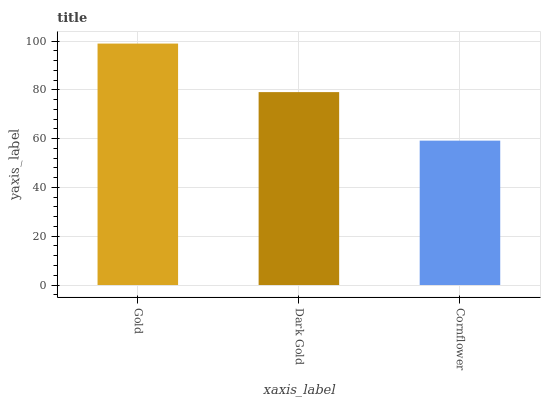Is Cornflower the minimum?
Answer yes or no. Yes. Is Gold the maximum?
Answer yes or no. Yes. Is Dark Gold the minimum?
Answer yes or no. No. Is Dark Gold the maximum?
Answer yes or no. No. Is Gold greater than Dark Gold?
Answer yes or no. Yes. Is Dark Gold less than Gold?
Answer yes or no. Yes. Is Dark Gold greater than Gold?
Answer yes or no. No. Is Gold less than Dark Gold?
Answer yes or no. No. Is Dark Gold the high median?
Answer yes or no. Yes. Is Dark Gold the low median?
Answer yes or no. Yes. Is Gold the high median?
Answer yes or no. No. Is Cornflower the low median?
Answer yes or no. No. 